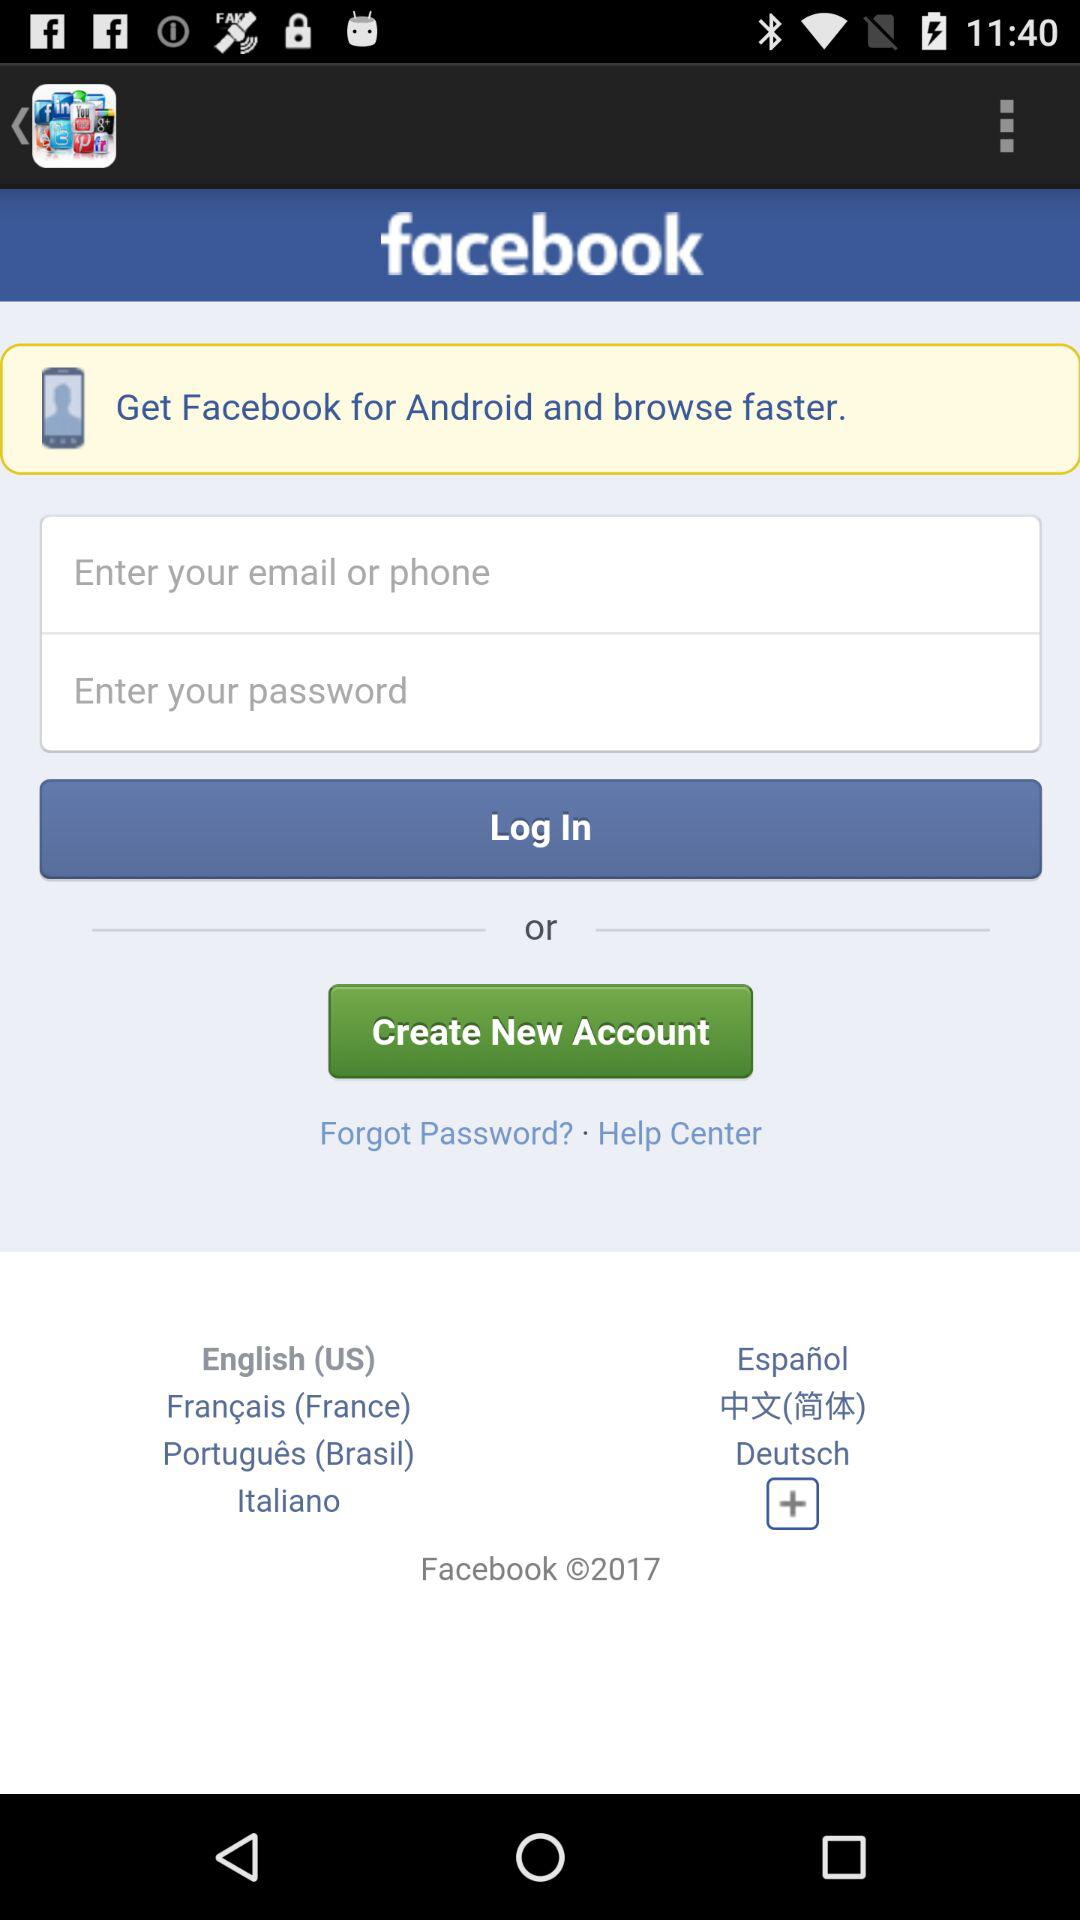How many languages are available to choose from?
Answer the question using a single word or phrase. 7 